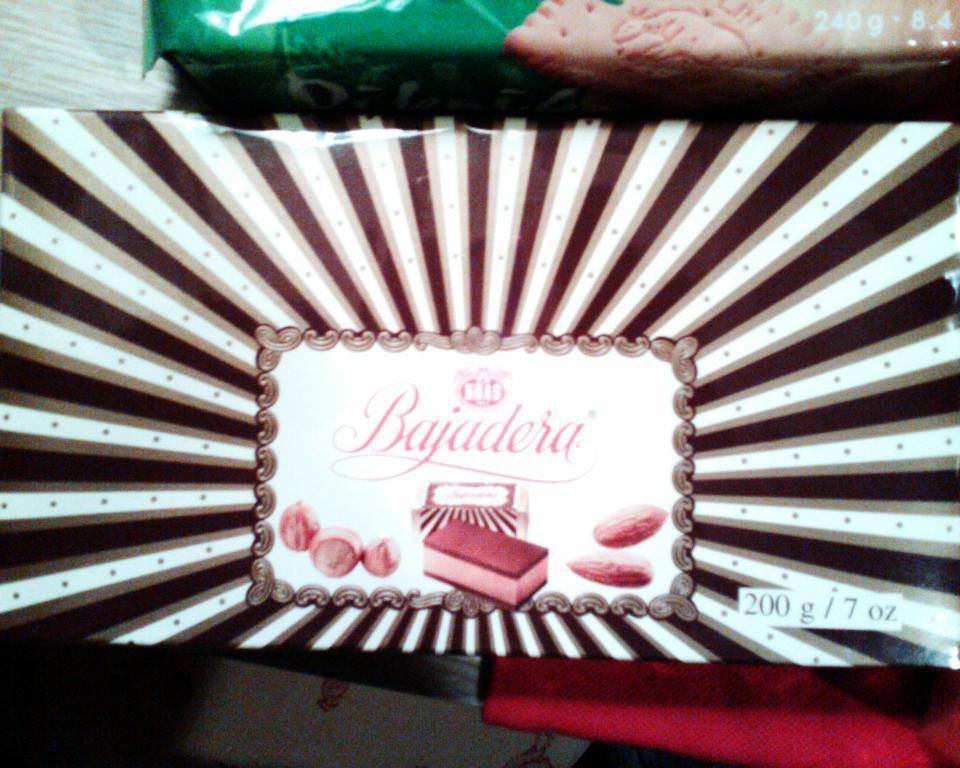Describe this image in one or two sentences. In the image there is a packet with images and some text on it. At the top of the image there is another packet. 